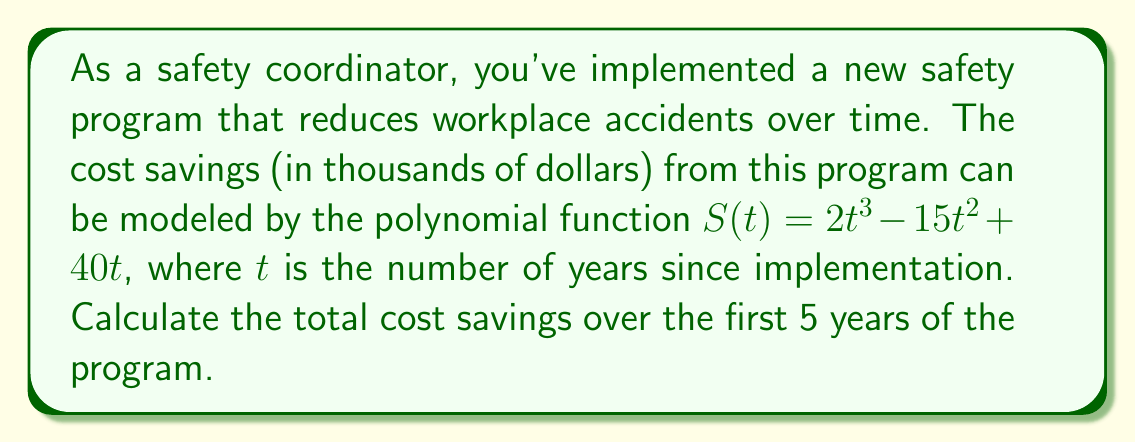Can you solve this math problem? To solve this problem, we need to find the definite integral of the given polynomial function from $t=0$ to $t=5$. This will give us the area under the curve, which represents the total cost savings over the 5-year period.

1. The given function is $S(t) = 2t^3 - 15t^2 + 40t$

2. To find the definite integral, we need to antidifferentiate the function:
   $$\int S(t) dt = \frac{1}{2}t^4 - 5t^3 + 20t^2 + C$$

3. Now, we'll evaluate this from $t=0$ to $t=5$:
   $$\int_0^5 S(t) dt = [\frac{1}{2}t^4 - 5t^3 + 20t^2]_0^5$$

4. Substitute the upper and lower bounds:
   $$= (\frac{1}{2}(5^4) - 5(5^3) + 20(5^2)) - (\frac{1}{2}(0^4) - 5(0^3) + 20(0^2))$$

5. Simplify:
   $$= (312.5 - 625 + 500) - (0 - 0 + 0)$$
   $$= 187.5 - 0 = 187.5$$

6. Since the function was in thousands of dollars, we multiply by 1000:
   $$187.5 * 1000 = 187,500$$

Therefore, the total cost savings over the first 5 years of the program is $187,500.
Answer: $187,500 